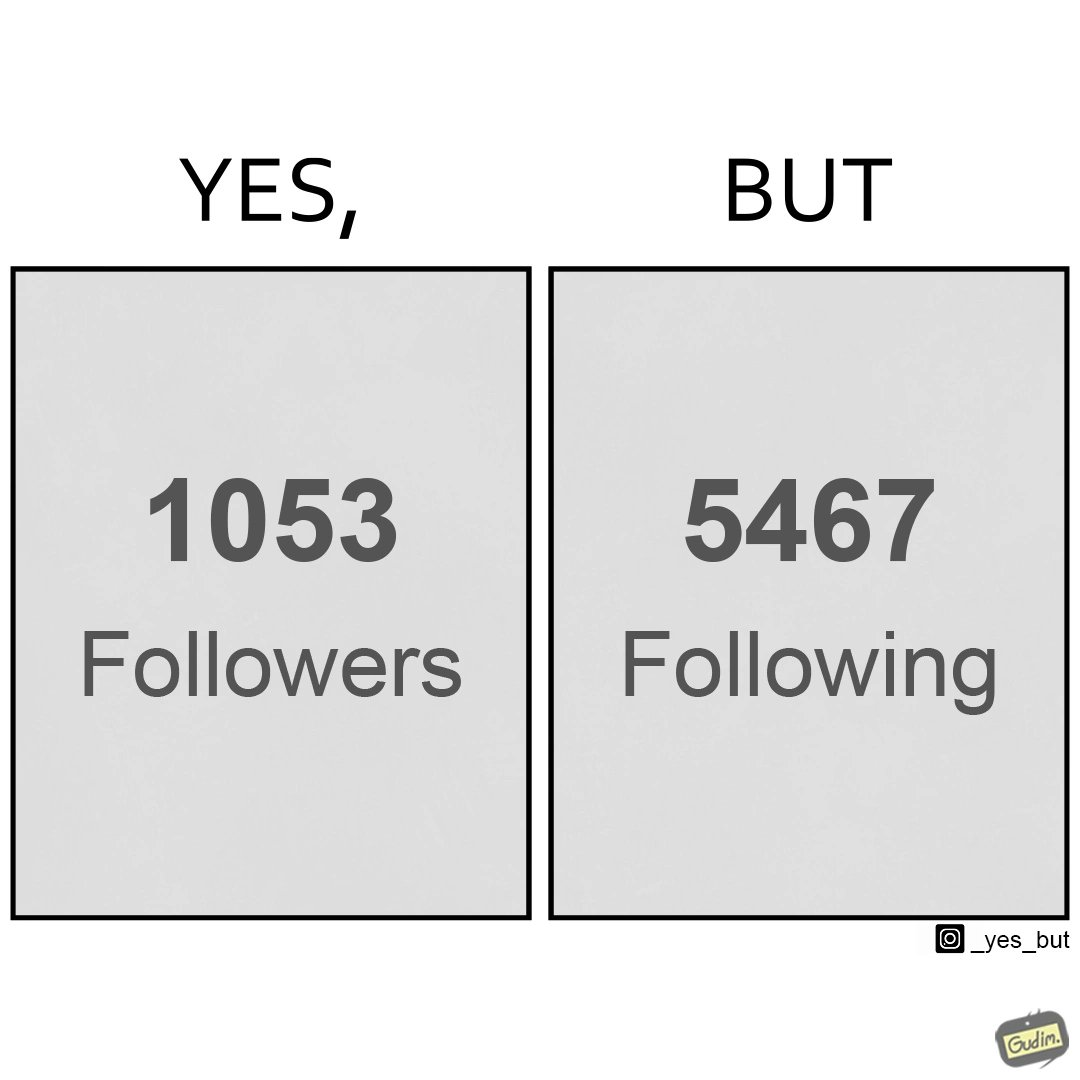Provide a description of this image. The image creates a comparison between the following and followers of a account which suggests that the person/organizations follows more people/organizations than being followed back 